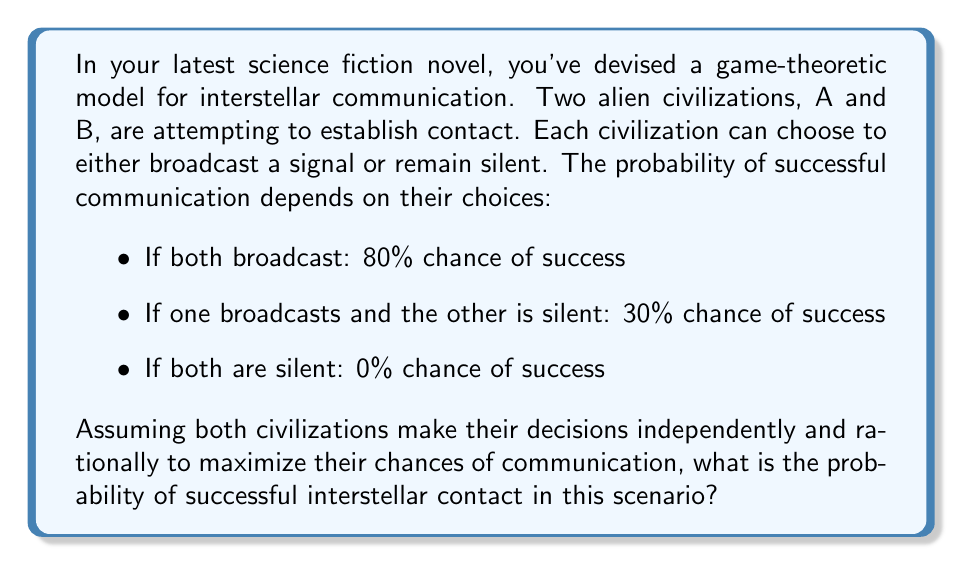Help me with this question. To solve this problem, we'll use game theory principles, specifically the concept of Nash equilibrium.

1) First, let's set up the payoff matrix for this game:

   $$
   \begin{array}{c|c|c}
    & \text{B Broadcasts} & \text{B Silent} \\
   \hline
   \text{A Broadcasts} & (0.8, 0.8) & (0.3, 0.3) \\
   \hline
   \text{A Silent} & (0.3, 0.3) & (0, 0)
   \end{array}
   $$

   The payoffs represent the probability of successful communication.

2) To find the Nash equilibrium, we need to determine if any player has an incentive to unilaterally change their strategy.

3) If B broadcasts, A's best response is to broadcast (0.8 > 0.3).
   If B is silent, A's best response is to broadcast (0.3 > 0).

4) The same is true for B. Therefore, the Nash equilibrium is for both civilizations to broadcast.

5) In this equilibrium, the probability of successful communication is 0.8 or 80%.

However, we need to consider if there are any mixed strategy equilibria:

6) Let $p$ be the probability that A broadcasts, and $q$ be the probability that B broadcasts.

7) For A to be indifferent between broadcasting and staying silent:

   $0.8q + 0.3(1-q) = 0.3q + 0(1-q)$
   $0.5q = 0.3$
   $q = 0.6$

8) Similarly for B:

   $0.8p + 0.3(1-p) = 0.3p + 0(1-p)$
   $0.5p = 0.3$
   $p = 0.6$

9) This means there is also a mixed strategy equilibrium where each civilization broadcasts with probability 0.6 and remains silent with probability 0.4.

10) In this mixed strategy equilibrium, the probability of successful communication is:

    $0.6 \cdot 0.6 \cdot 0.8 + 0.6 \cdot 0.4 \cdot 0.3 + 0.4 \cdot 0.6 \cdot 0.3 + 0.4 \cdot 0.4 \cdot 0 = 0.384$ or 38.4%

11) Since both civilizations are rational and want to maximize their chances of communication, they would choose the pure strategy equilibrium (both broadcasting) over the mixed strategy equilibrium.

Therefore, the probability of successful interstellar contact in this scenario is 80%.
Answer: 80% 